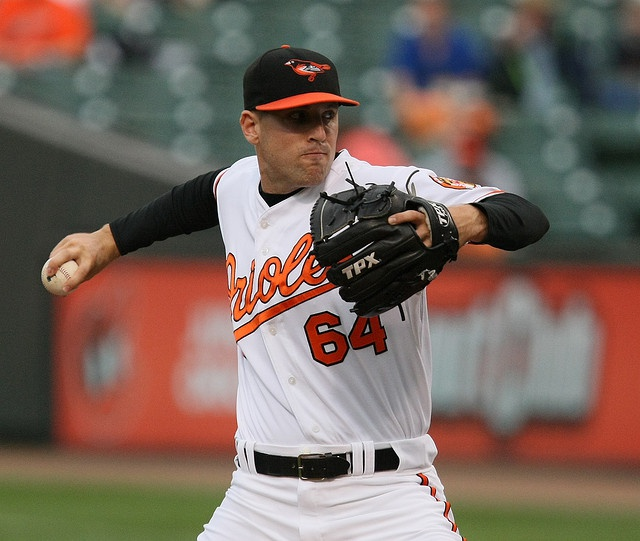Describe the objects in this image and their specific colors. I can see people in red, lightgray, black, darkgray, and gray tones, baseball glove in red, black, gray, darkgray, and maroon tones, and sports ball in red, tan, and gray tones in this image. 